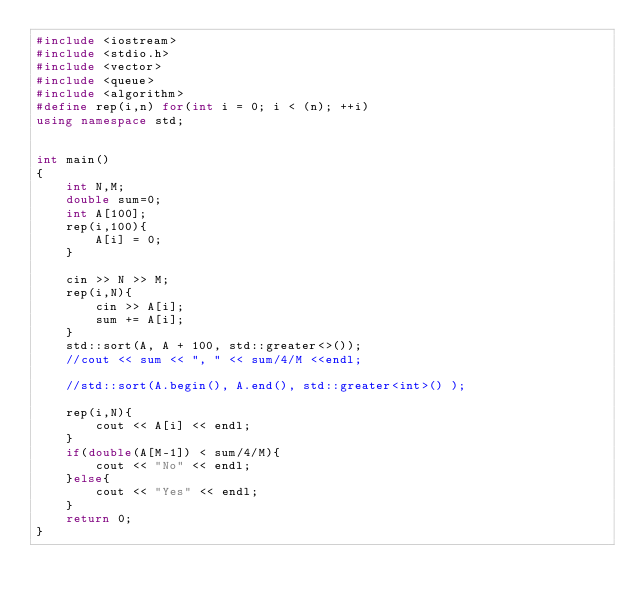<code> <loc_0><loc_0><loc_500><loc_500><_C++_>#include <iostream>
#include <stdio.h>
#include <vector>
#include <queue>
#include <algorithm>
#define rep(i,n) for(int i = 0; i < (n); ++i)
using namespace std;


int main()
{
    int N,M;
    double sum=0;
    int A[100];
    rep(i,100){
        A[i] = 0;
    }

    cin >> N >> M;
    rep(i,N){
        cin >> A[i];
        sum += A[i];
    }
    std::sort(A, A + 100, std::greater<>());
    //cout << sum << ", " << sum/4/M <<endl;

    //std::sort(A.begin(), A.end(), std::greater<int>() );

    rep(i,N){
        cout << A[i] << endl;
    }
    if(double(A[M-1]) < sum/4/M){
        cout << "No" << endl;
    }else{
        cout << "Yes" << endl;
    }
    return 0;
}</code> 